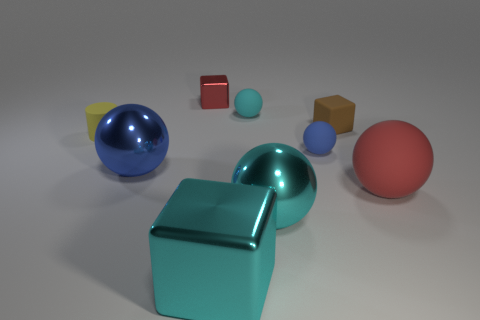Can you tell which object stands out the most due to its size? The blue sphere stands out the most due to its size; it is significantly larger than the other objects in the image. 